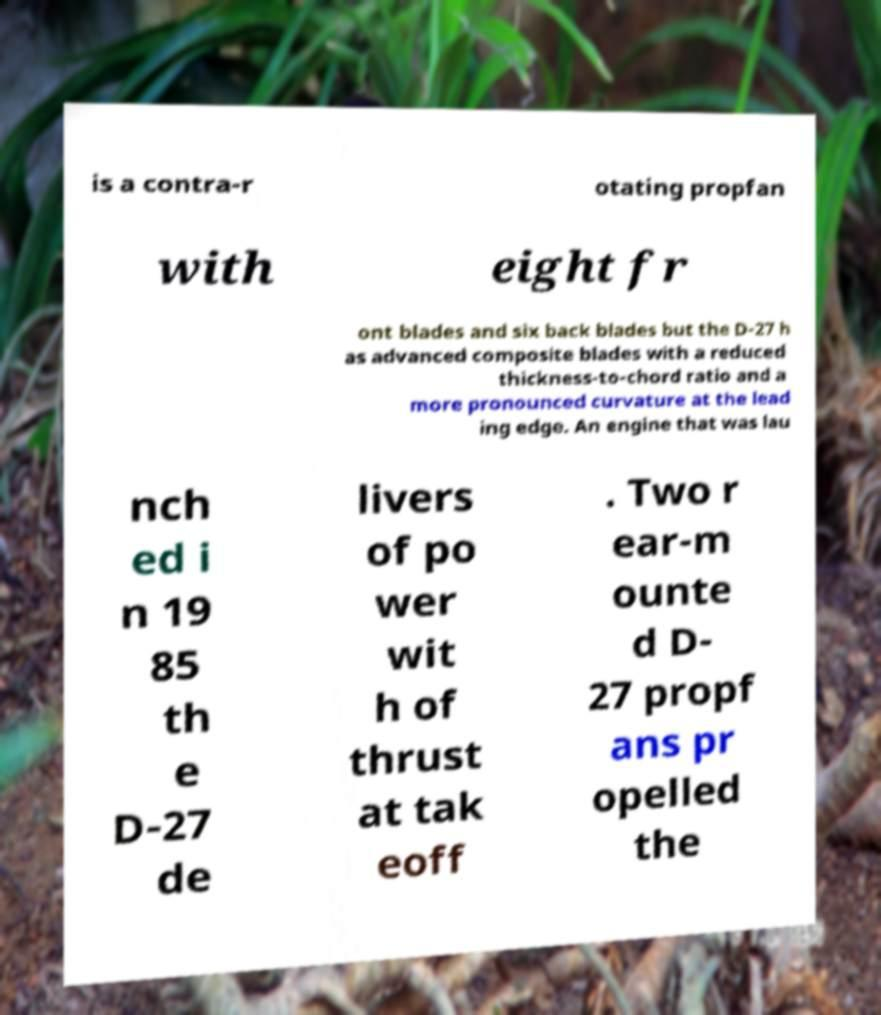Please read and relay the text visible in this image. What does it say? is a contra-r otating propfan with eight fr ont blades and six back blades but the D-27 h as advanced composite blades with a reduced thickness-to-chord ratio and a more pronounced curvature at the lead ing edge. An engine that was lau nch ed i n 19 85 th e D-27 de livers of po wer wit h of thrust at tak eoff . Two r ear-m ounte d D- 27 propf ans pr opelled the 